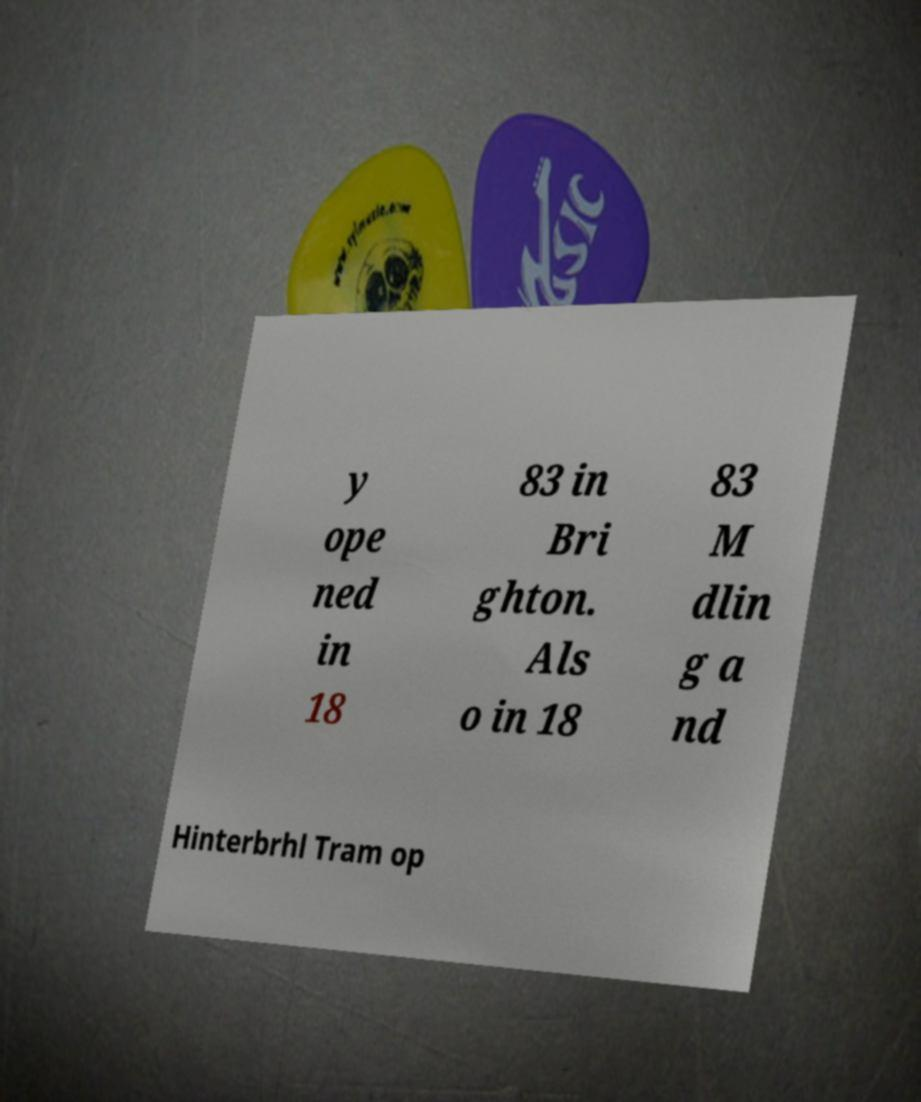Could you assist in decoding the text presented in this image and type it out clearly? y ope ned in 18 83 in Bri ghton. Als o in 18 83 M dlin g a nd Hinterbrhl Tram op 